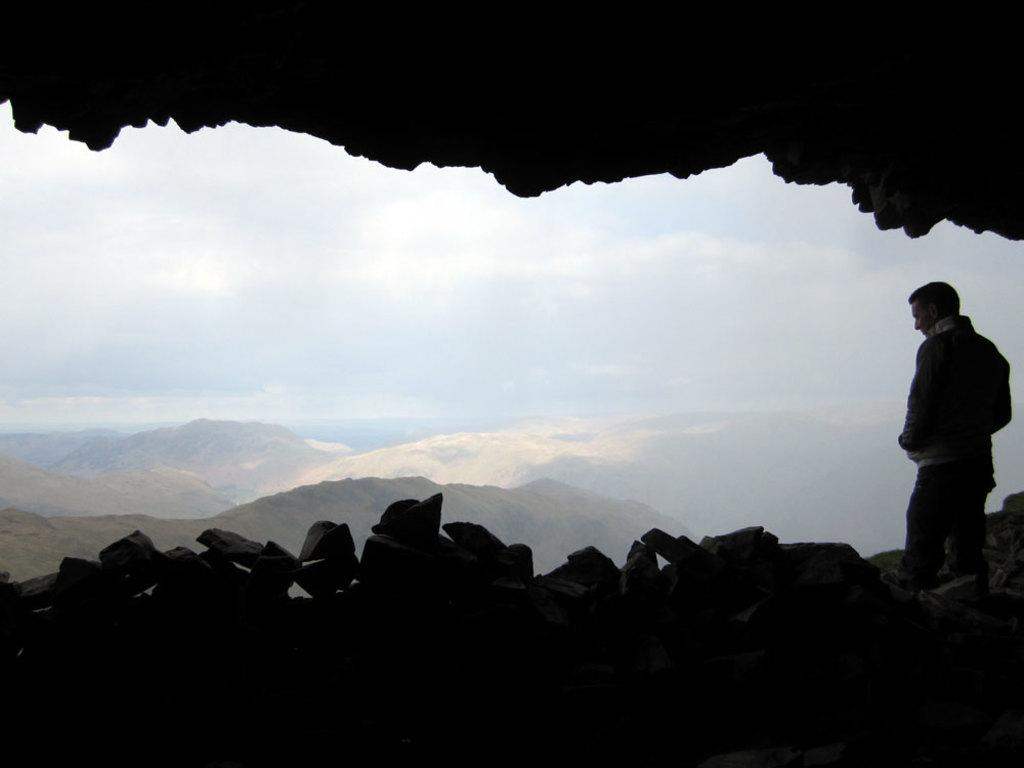What is the position of the person in the image? There is a person standing on the right side of the image. What can be seen in the background of the image? There are rocks and mountains in the background of the image. What is the condition of the sky in the image? The sky is cloudy in the image. What is the person's father doing in the image? There is no information about the person's father in the image, so we cannot answer that question. 